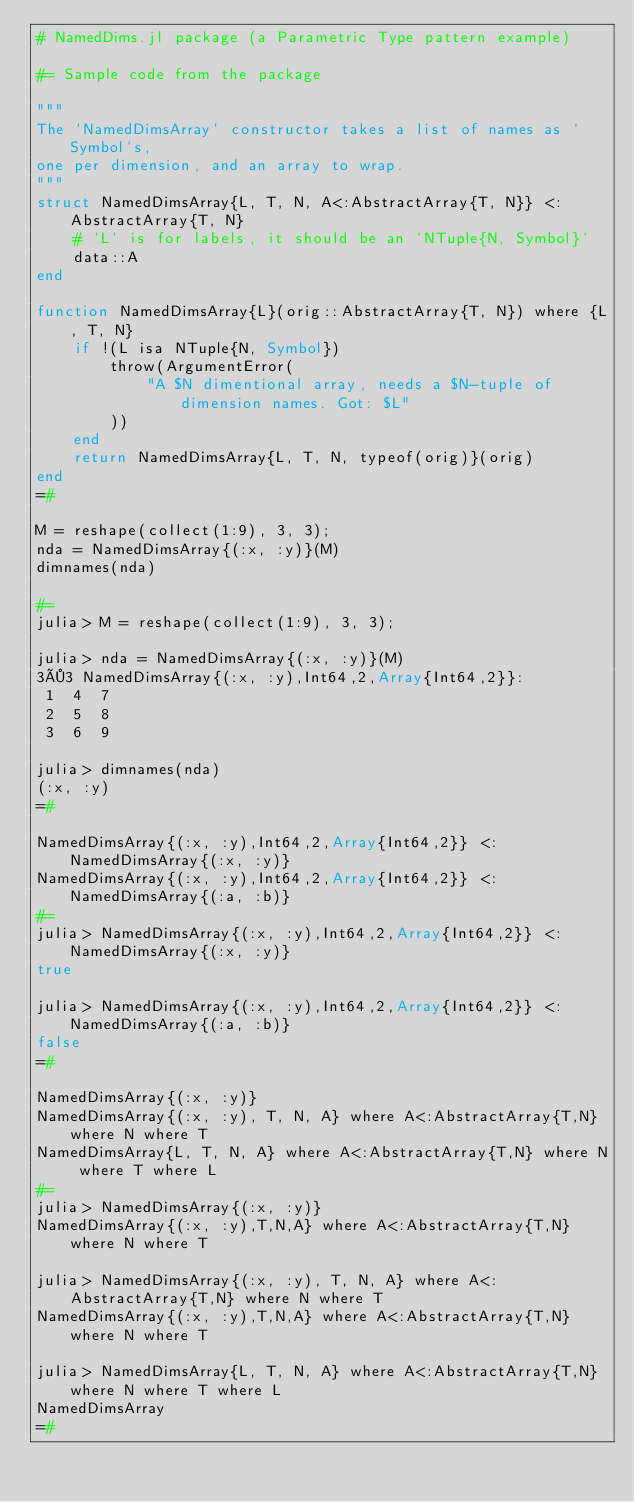<code> <loc_0><loc_0><loc_500><loc_500><_Julia_># NamedDims.jl package (a Parametric Type pattern example)

#= Sample code from the package

"""
The `NamedDimsArray` constructor takes a list of names as `Symbol`s,
one per dimension, and an array to wrap.
"""
struct NamedDimsArray{L, T, N, A<:AbstractArray{T, N}} <: AbstractArray{T, N}
    # `L` is for labels, it should be an `NTuple{N, Symbol}`
    data::A
end

function NamedDimsArray{L}(orig::AbstractArray{T, N}) where {L, T, N}
    if !(L isa NTuple{N, Symbol})
        throw(ArgumentError(
            "A $N dimentional array, needs a $N-tuple of dimension names. Got: $L"
        ))
    end
    return NamedDimsArray{L, T, N, typeof(orig)}(orig)
end
=#

M = reshape(collect(1:9), 3, 3);
nda = NamedDimsArray{(:x, :y)}(M)
dimnames(nda)

#=
julia> M = reshape(collect(1:9), 3, 3);

julia> nda = NamedDimsArray{(:x, :y)}(M)
3×3 NamedDimsArray{(:x, :y),Int64,2,Array{Int64,2}}:
 1  4  7
 2  5  8
 3  6  9

julia> dimnames(nda)
(:x, :y)
=#

NamedDimsArray{(:x, :y),Int64,2,Array{Int64,2}} <: NamedDimsArray{(:x, :y)}
NamedDimsArray{(:x, :y),Int64,2,Array{Int64,2}} <: NamedDimsArray{(:a, :b)}
#=
julia> NamedDimsArray{(:x, :y),Int64,2,Array{Int64,2}} <: NamedDimsArray{(:x, :y)}
true

julia> NamedDimsArray{(:x, :y),Int64,2,Array{Int64,2}} <: NamedDimsArray{(:a, :b)}
false
=#

NamedDimsArray{(:x, :y)}
NamedDimsArray{(:x, :y), T, N, A} where A<:AbstractArray{T,N} where N where T 
NamedDimsArray{L, T, N, A} where A<:AbstractArray{T,N} where N where T where L
#=
julia> NamedDimsArray{(:x, :y)}
NamedDimsArray{(:x, :y),T,N,A} where A<:AbstractArray{T,N} where N where T

julia> NamedDimsArray{(:x, :y), T, N, A} where A<:AbstractArray{T,N} where N where T 
NamedDimsArray{(:x, :y),T,N,A} where A<:AbstractArray{T,N} where N where T

julia> NamedDimsArray{L, T, N, A} where A<:AbstractArray{T,N} where N where T where L
NamedDimsArray
=#
</code> 